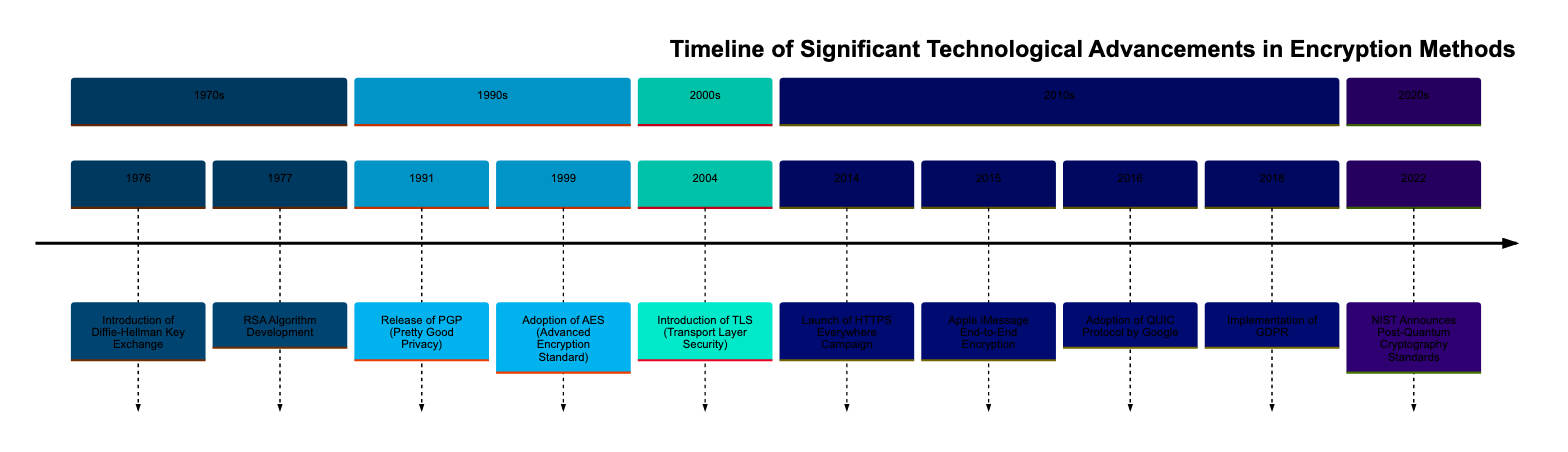What year was the RSA algorithm developed? The diagram lists the event "RSA Algorithm Development" in the year 1977. This is a specific event that highlights a key development in encryption methods.
Answer: 1977 What significant encryption method was released in 1991? The diagram indicates the event "Release of PGP (Pretty Good Privacy)" occurring in 1991. This event marks a notable advancement in encryption for secure communication.
Answer: PGP (Pretty Good Privacy) How many events are listed in the 2010s section of the timeline? By examining the 2010s section on the timeline, there are four distinct events: the launch of HTTPS Everywhere, Apple iMessage end-to-end encryption, the adoption of QUIC protocol, and the implementation of GDPR. This adds up to four events total.
Answer: 4 What encryption standard was adopted in 1999? The timeline mentions "Adoption of AES (Advanced Encryption Standard)" in the year 1999, indicating a pivotal moment for encryption in various sectors.
Answer: AES (Advanced Encryption Standard) Which year saw the introduction of TLS? According to the diagram, the event "Introduction of TLS (Transport Layer Security)" is marked in the year 2004, indicating its first introduction into widespread use.
Answer: 2004 What was the primary purpose of the HTTPS Everywhere Campaign initiated in 2014? The diagram describes the "Launch of HTTPS Everywhere Campaign" in 2014 with the objective of promoting the use of HTTPS to encrypt web traffic, making internet communications more secure.
Answer: Encrypt web traffic Which encryption method did Apple implement in 2015? The timeline clearly states that in 2015, "Apple iMessage End-to-End Encryption" was introduced, showcasing Apple's advancements in ensuring user privacy through encryption.
Answer: iMessage End-to-End Encryption What did NIST announce in 2022 regarding encryption? The diagram highlights the event "NIST Announces Post-Quantum Cryptography Standards" in 2022, indicating a proactive step towards preparing encryption methods against the potential threats posed by quantum computing.
Answer: Post-Quantum Cryptography Standards Which event marked the beginning of public-key cryptography? The timeline points to the year 1976, which details the "Introduction of Diffie-Hellman Key Exchange," marking the pivotal start of public-key cryptography's impact on secure communications.
Answer: Introduction of Diffie-Hellman Key Exchange 